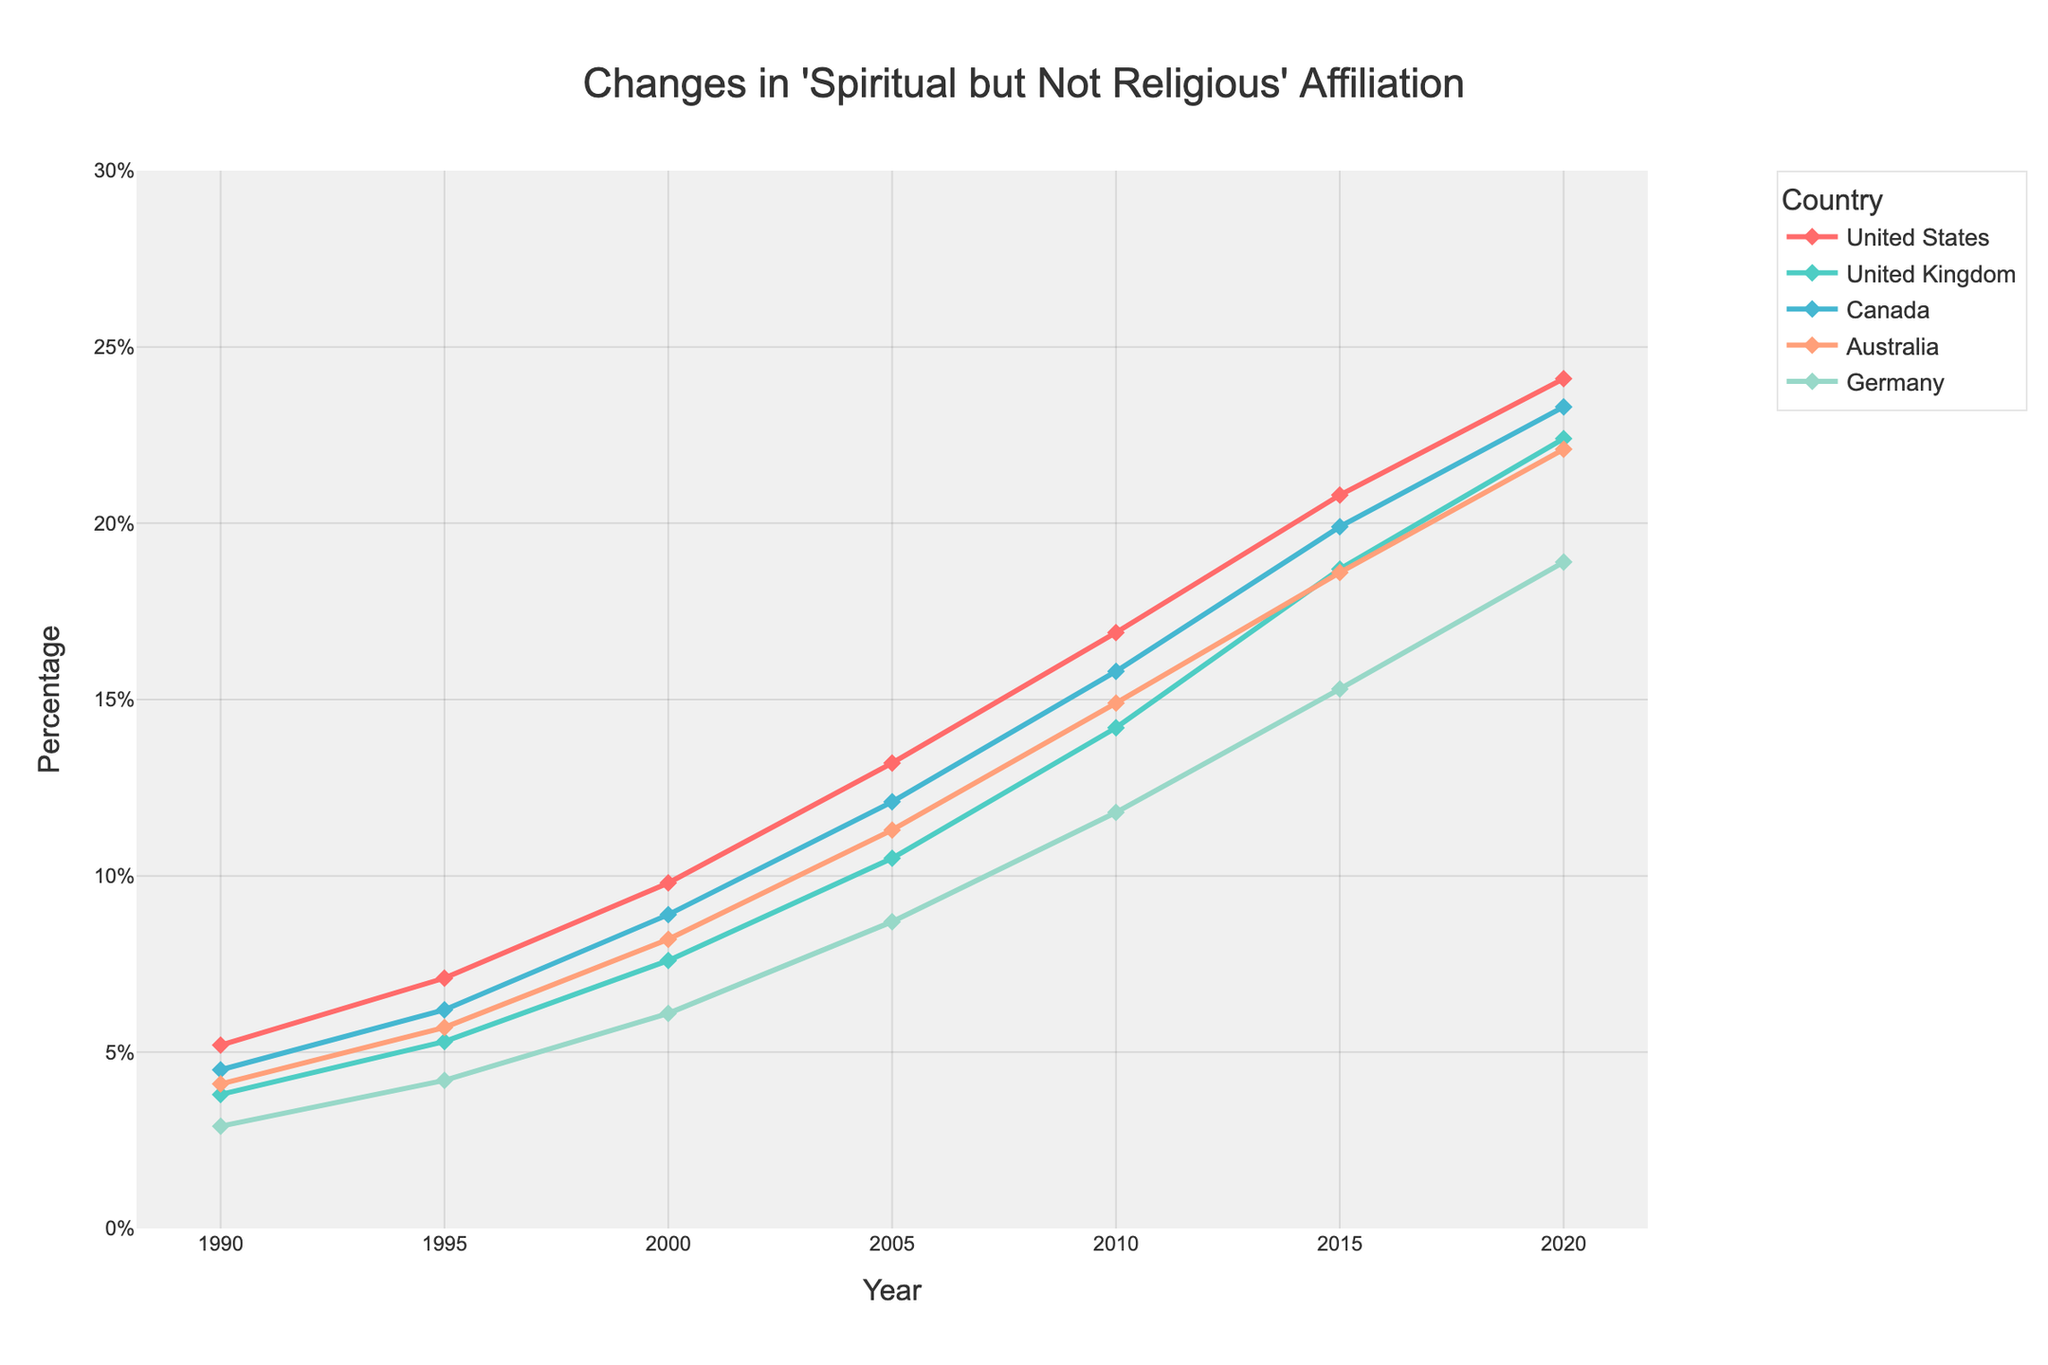What is the overall trend in the percentage of people identifying as 'spiritual but not religious' from 1990 to 2020 across the five countries? The overall trend for all five countries shows a consistent increase in the percentage of people identifying as 'spiritual but not religious' from 1990 to 2020. This is indicated by the upward slopes of all the lines representing each country in the chart.
Answer: Increasing Which country had the highest percentage of people identifying as 'spiritual but not religious' in 2020? By observing the values at the end of the lines for the year 2020, the United States has the highest percentage at 24.1%.
Answer: United States Between 1990 and 2020, which country showed the largest absolute increase in the percentage of people identifying as 'spiritual but not religious'? Calculate the difference between the percentages in 2020 and 1990 for each country. For the United States: 24.1% - 5.2% = 18.9%, for the United Kingdom: 22.4% - 3.8% = 18.6%, for Canada: 23.3% - 4.5% = 18.8%, for Australia: 22.1% - 4.1% = 18.0%, and for Germany: 18.9% - 2.9% = 16.0%. The United States shows the largest increase of 18.9%.
Answer: United States Which years show noticeable consistent increases in the percentage for the United Kingdom? Visually inspecting the line for the United Kingdom, consistent noticeable increases occur between all consecutive years without any decline or stabilization, from 1990 to 2020.
Answer: 1990 to 2020 What is the average percentage of people identifying as 'spiritual but not religious' in Australia from 1990 to 2020? Add the percentages for Australia from each year and divide by the number of years: (4.1 + 5.7 + 8.2 + 11.3 + 14.9 + 18.6 + 22.1) / 7 = 85.9 / 7 = 12.27%.
Answer: 12.27% Between 2000 and 2010, which country had the highest growth rate in the percentage of people identifying as 'spiritual but not religious'? Calculate the growth rate for each country: for the United States: (16.9 - 9.8) / 9.8 = 71.83%, for the United Kingdom: (14.2 - 7.6) / 7.6 = 86.84%, for Canada: (15.8 - 8.9) / 8.9 = 77.53%, for Australia: (14.9 - 8.2) / 8.2 = 81.71%, for Germany: (11.8 - 6.1) / 6.1 = 93.44%. Germany had the highest growth rate of 93.44%.
Answer: Germany How does the percentage of people identifying as 'spiritual but not religious' in Germany compare to the United States in 2015? In 2015, the percentage for Germany is 15.3% and for the United States is 20.8%. The percentage in Germany is less than that in the United States for this year.
Answer: Less Which country shows the smallest increase in the percentage of people identifying as 'spiritual but not religious' from 1990 to 2020, and what is that increase? Calculate the difference for each country: for the United States: 24.1% - 5.2% = 18.9%, for the United Kingdom: 22.4% - 3.8% = 18.6%, for Canada: 23.3% - 4.5% = 18.8%, for Australia: 22.1% - 4.1% = 18.0%, and for Germany: 18.9% - 2.9% = 16.0%. Germany has the smallest increase of 16.0%.
Answer: Germany, 16.0% What is the total percentage increase in people identifying as 'spiritual but not religious' from 1990 to 2000 across all five countries? Calculate the sum of the increases for each country from 1990 to 2000: (9.8 - 5.2) + (7.6 - 3.8) + (8.9 - 4.5) + (8.2 - 4.1) + (6.1 - 2.9) = 4.6 + 3.8 + 4.4 + 4.1 + 3.2 = 20.1%.
Answer: 20.1% 